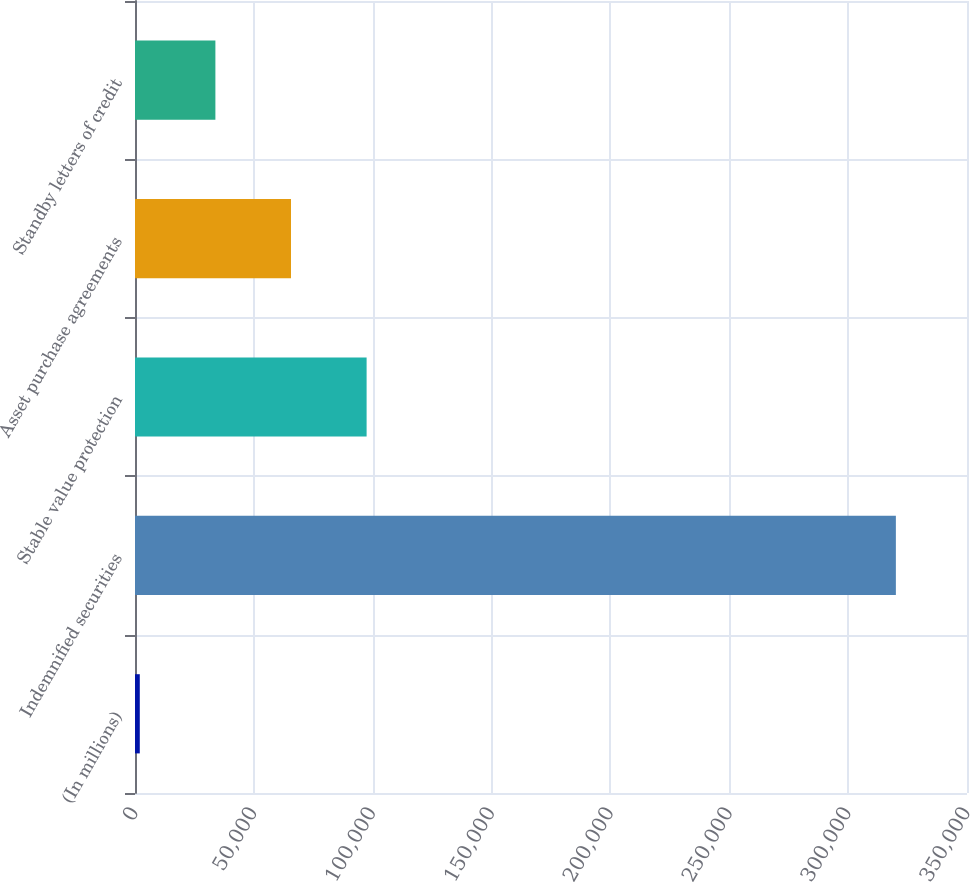<chart> <loc_0><loc_0><loc_500><loc_500><bar_chart><fcel>(In millions)<fcel>Indemnified securities<fcel>Stable value protection<fcel>Asset purchase agreements<fcel>Standby letters of credit<nl><fcel>2013<fcel>320078<fcel>97432.5<fcel>65626<fcel>33819.5<nl></chart> 